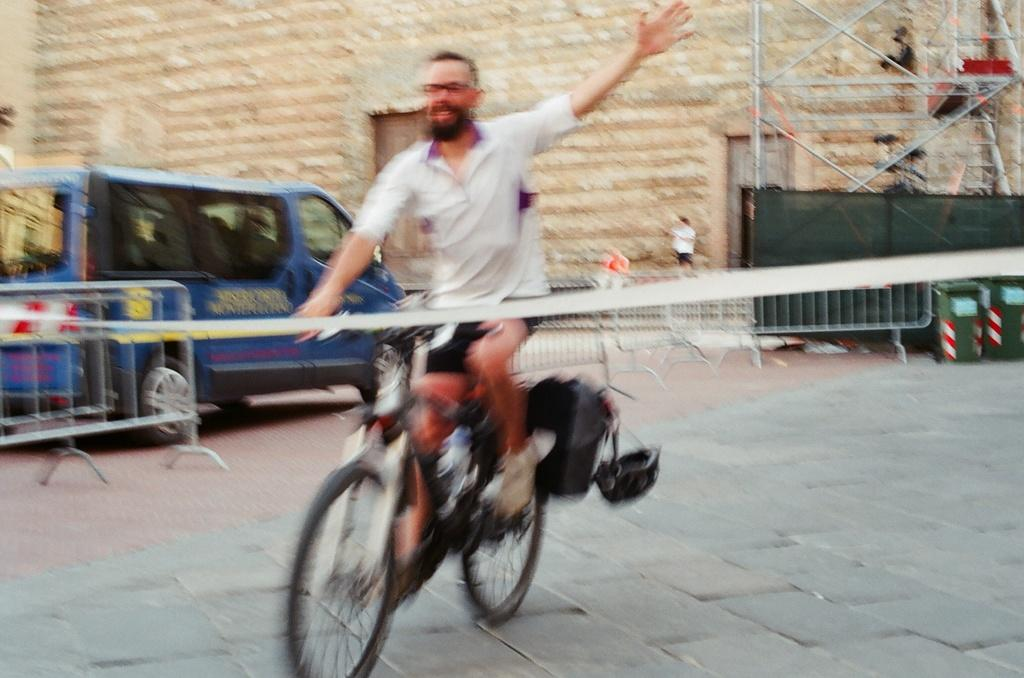What is the man in the image doing? The man is riding a bicycle in the image. What type of vehicle can be seen in the image? There is a blue vehicle in the image. Can you describe the building in the image? There is a building with a door in the image. What is the name of the idea that the man is riding the bicycle in the image? There is no idea present in the image, and therefore no name can be assigned to it. 